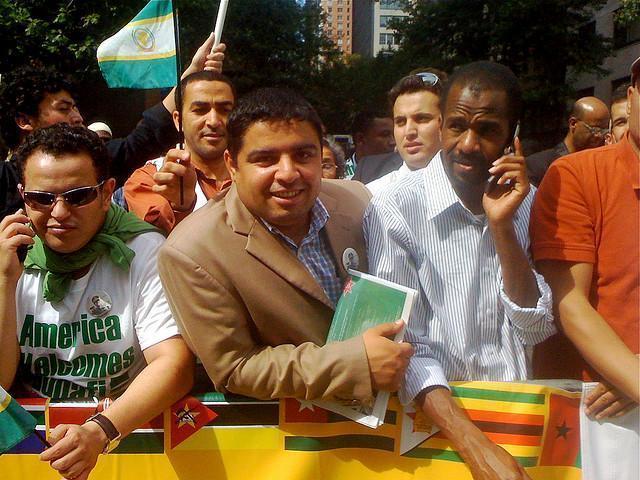What is the man holding the paper wearing?
Pick the correct solution from the four options below to address the question.
Options: Glasses, gas mask, suit, cowboy hat. Suit. 